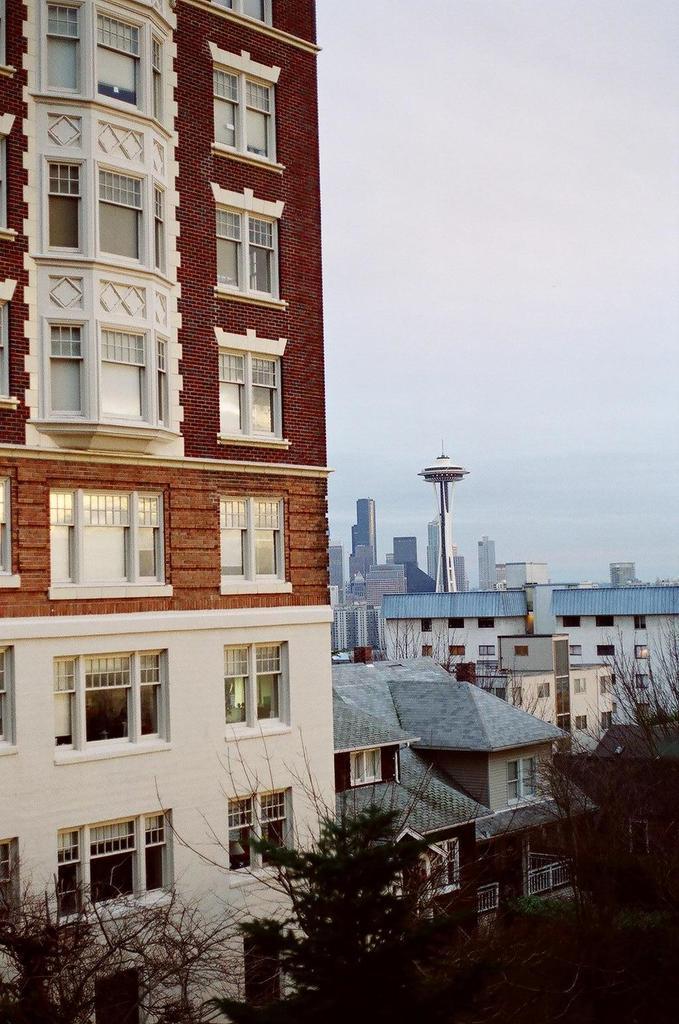Could you give a brief overview of what you see in this image? In this image we can see the buildings, trees and also the sky. 